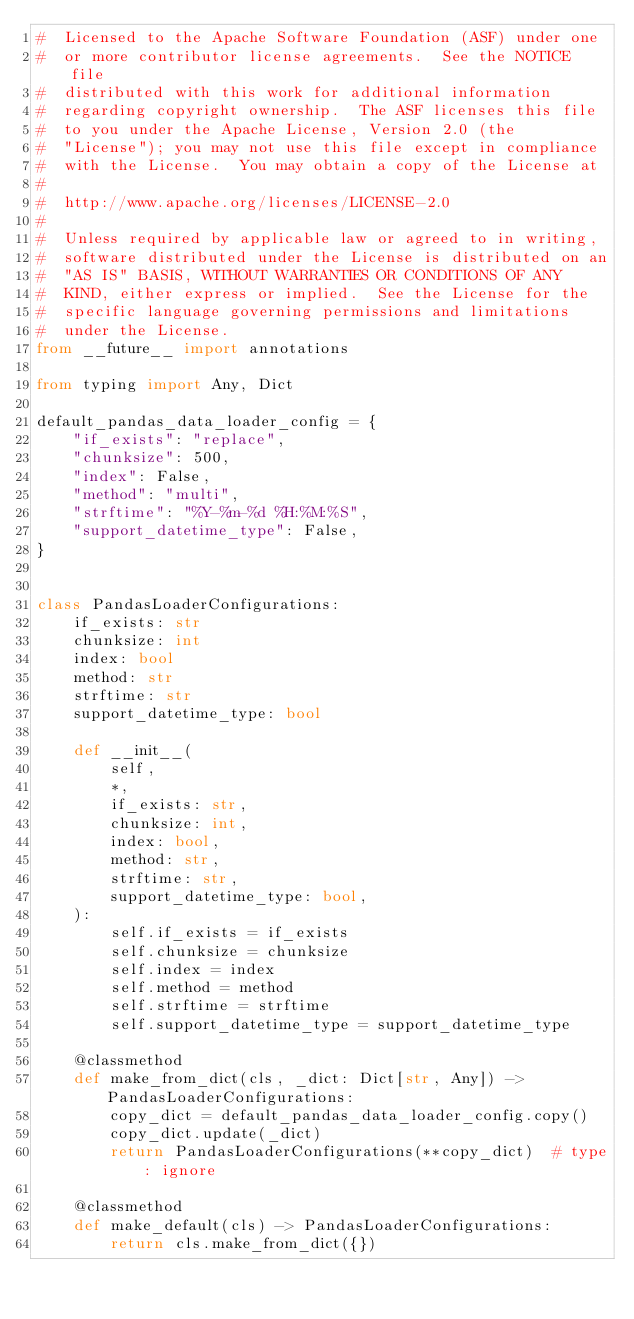Convert code to text. <code><loc_0><loc_0><loc_500><loc_500><_Python_>#  Licensed to the Apache Software Foundation (ASF) under one
#  or more contributor license agreements.  See the NOTICE file
#  distributed with this work for additional information
#  regarding copyright ownership.  The ASF licenses this file
#  to you under the Apache License, Version 2.0 (the
#  "License"); you may not use this file except in compliance
#  with the License.  You may obtain a copy of the License at
#
#  http://www.apache.org/licenses/LICENSE-2.0
#
#  Unless required by applicable law or agreed to in writing,
#  software distributed under the License is distributed on an
#  "AS IS" BASIS, WITHOUT WARRANTIES OR CONDITIONS OF ANY
#  KIND, either express or implied.  See the License for the
#  specific language governing permissions and limitations
#  under the License.
from __future__ import annotations

from typing import Any, Dict

default_pandas_data_loader_config = {
    "if_exists": "replace",
    "chunksize": 500,
    "index": False,
    "method": "multi",
    "strftime": "%Y-%m-%d %H:%M:%S",
    "support_datetime_type": False,
}


class PandasLoaderConfigurations:
    if_exists: str
    chunksize: int
    index: bool
    method: str
    strftime: str
    support_datetime_type: bool

    def __init__(
        self,
        *,
        if_exists: str,
        chunksize: int,
        index: bool,
        method: str,
        strftime: str,
        support_datetime_type: bool,
    ):
        self.if_exists = if_exists
        self.chunksize = chunksize
        self.index = index
        self.method = method
        self.strftime = strftime
        self.support_datetime_type = support_datetime_type

    @classmethod
    def make_from_dict(cls, _dict: Dict[str, Any]) -> PandasLoaderConfigurations:
        copy_dict = default_pandas_data_loader_config.copy()
        copy_dict.update(_dict)
        return PandasLoaderConfigurations(**copy_dict)  # type: ignore

    @classmethod
    def make_default(cls) -> PandasLoaderConfigurations:
        return cls.make_from_dict({})
</code> 